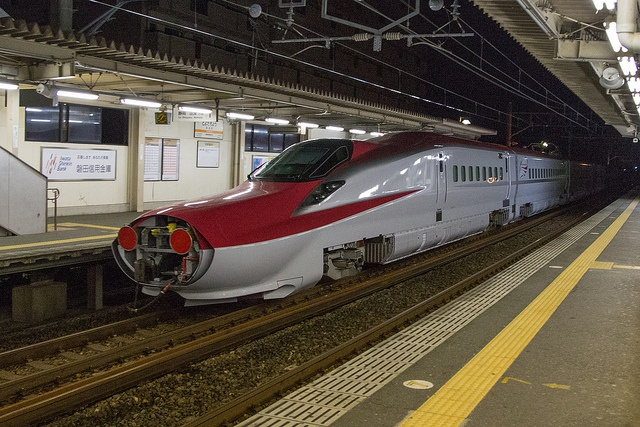Describe the objects in this image and their specific colors. I can see a train in black, gray, and maroon tones in this image. 